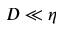Convert formula to latex. <formula><loc_0><loc_0><loc_500><loc_500>D \ll \eta</formula> 